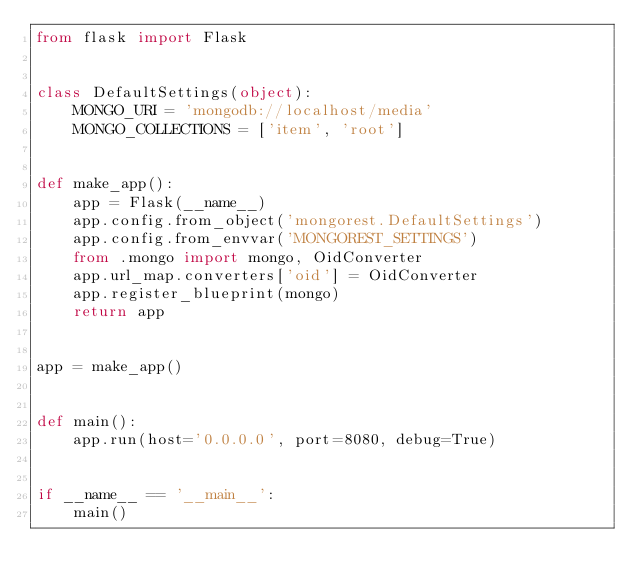Convert code to text. <code><loc_0><loc_0><loc_500><loc_500><_Python_>from flask import Flask


class DefaultSettings(object):
    MONGO_URI = 'mongodb://localhost/media'
    MONGO_COLLECTIONS = ['item', 'root']


def make_app():
    app = Flask(__name__)
    app.config.from_object('mongorest.DefaultSettings')
    app.config.from_envvar('MONGOREST_SETTINGS')
    from .mongo import mongo, OidConverter
    app.url_map.converters['oid'] = OidConverter
    app.register_blueprint(mongo)
    return app


app = make_app()


def main():
    app.run(host='0.0.0.0', port=8080, debug=True)


if __name__ == '__main__':
    main()
</code> 